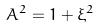<formula> <loc_0><loc_0><loc_500><loc_500>A ^ { 2 } = 1 + \xi ^ { 2 }</formula> 